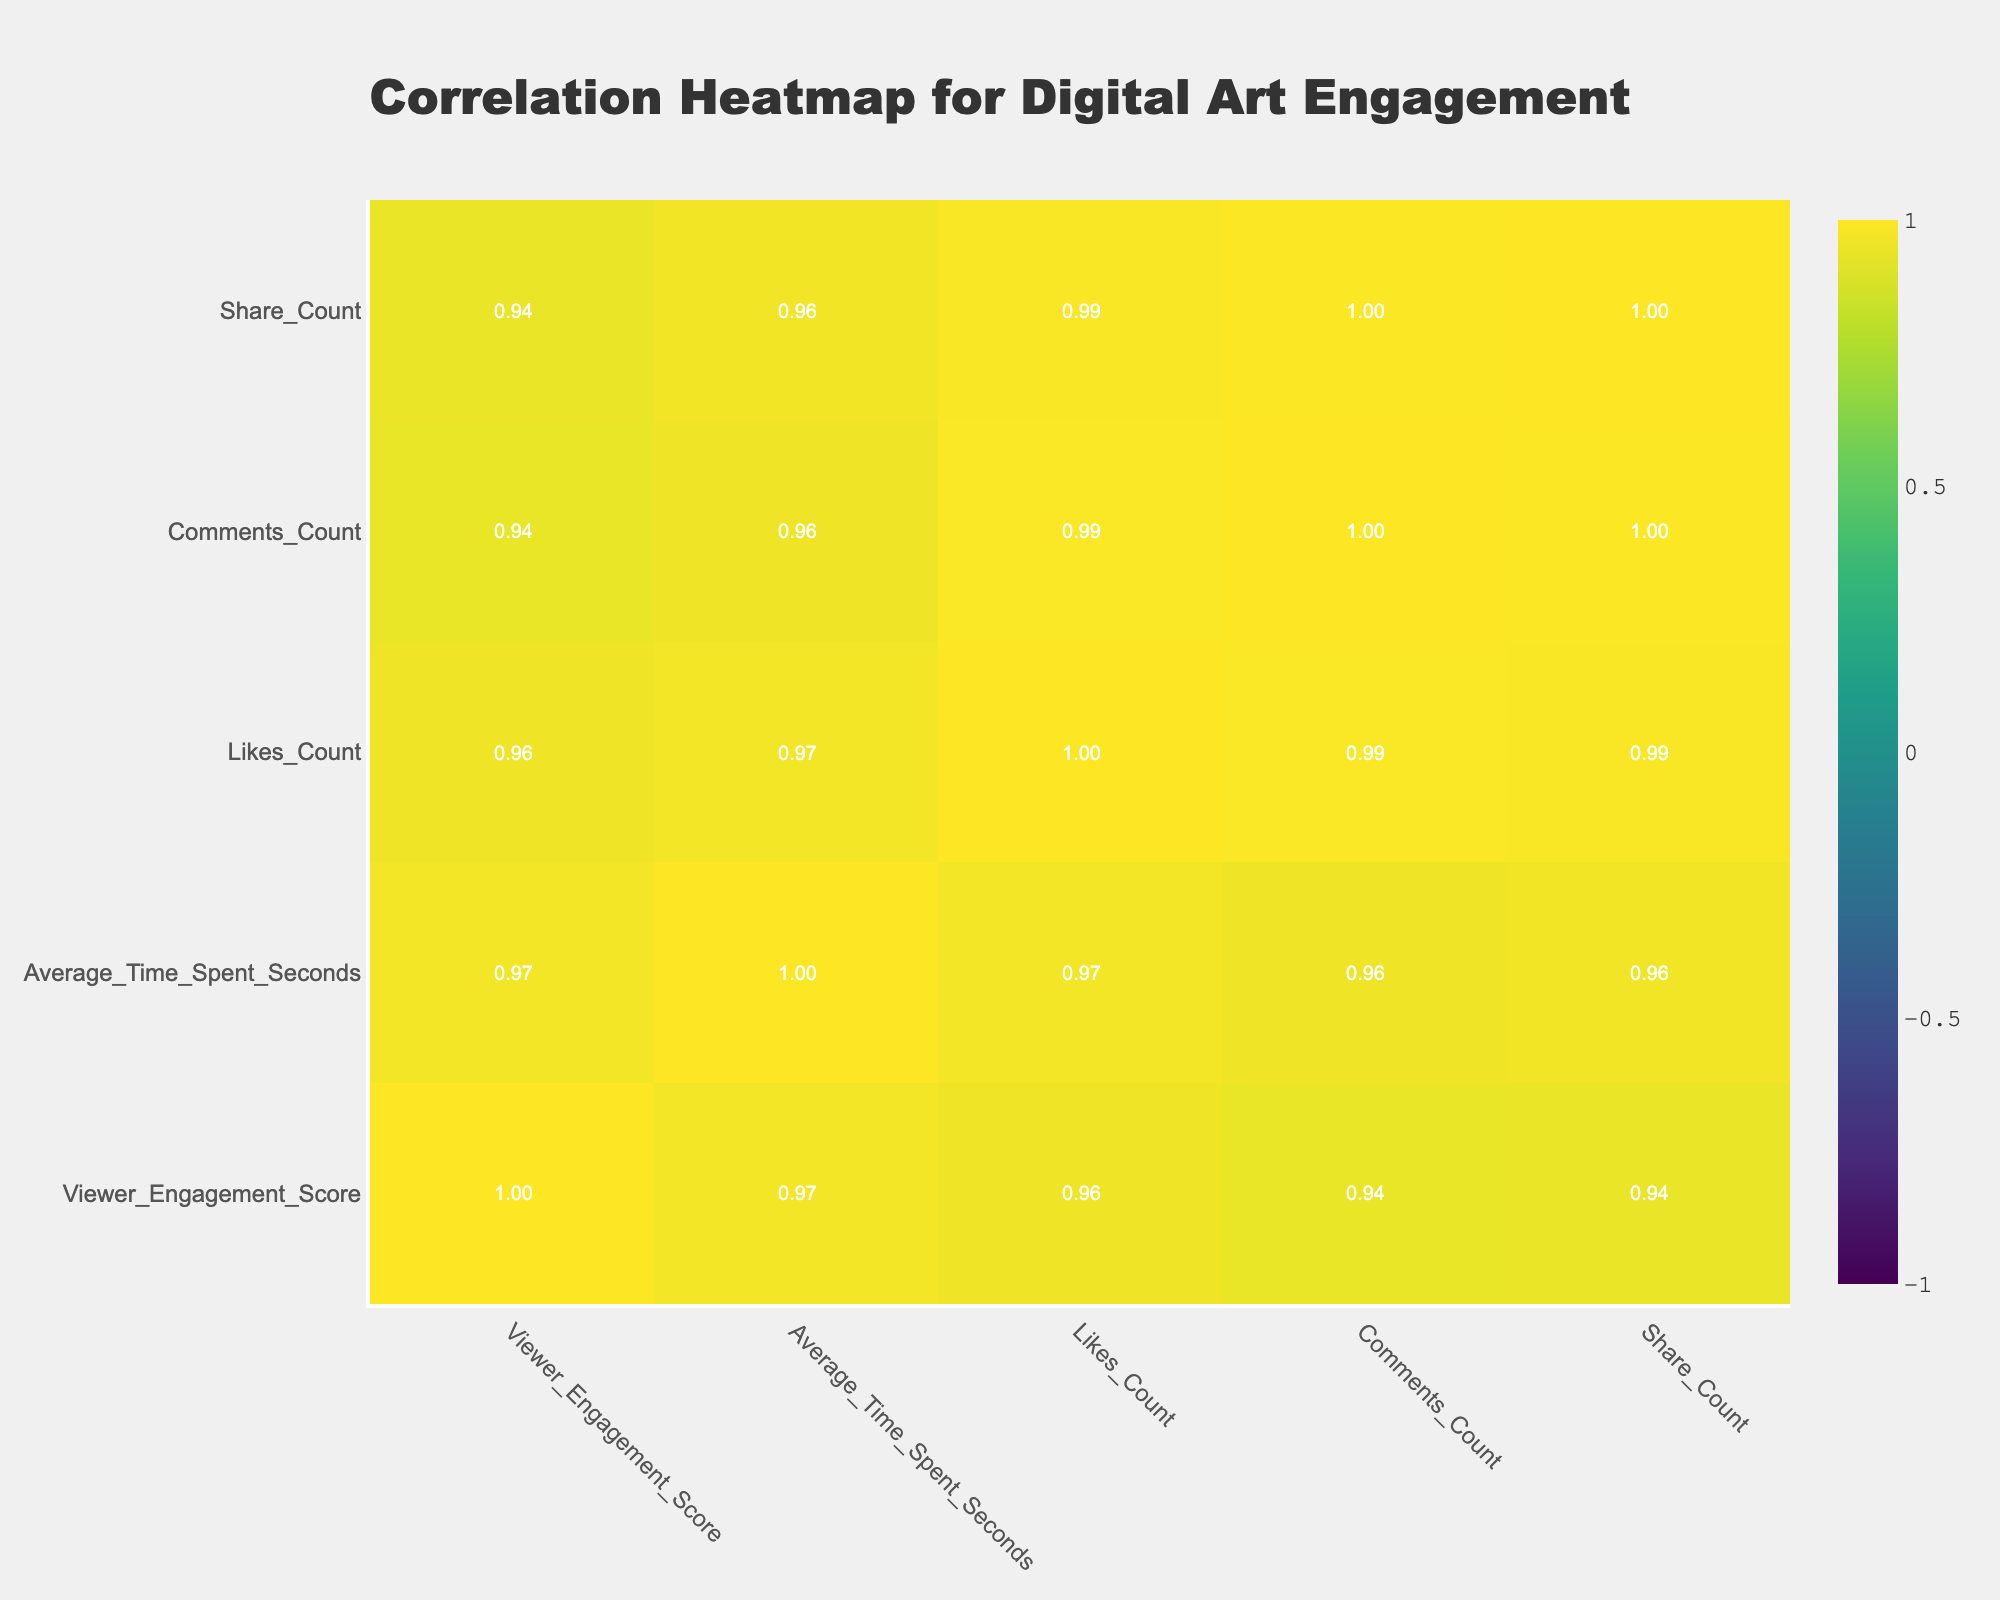What's the Viewer Engagement Score for the Neon color palette? The table shows the Neon color palette with a Viewer Engagement Score of 90.
Answer: 90 What color palette has the highest Likes Count? By checking the Likes Count column, Neon has the highest value at 250.
Answer: Neon Is the average time spent on digital art with a Muted color palette greater than 180 seconds? The average time spent for the Muted palette is 180 seconds, which is equal, not greater.
Answer: No Which color palette category has the lowest Comments Count? The table indicates that the Earthy color palette has the lowest Comments Count, standing at 3.
Answer: Earthy What is the correlation between Viewer Engagement Score and Share Count? Looking at the correlation table, the value for Viewer Engagement Score and Share Count is 0.88, indicating a strong positive correlation.
Answer: 0.88 What is the difference in Viewer Engagement Scores between the Vibrant and Monochromatic color palettes? Vibrant has a score of 76 while Monochromatic has 70. The difference is 76 - 70 = 6.
Answer: 6 Are there more color palettes with Viewer Engagement Scores above 70 than below 60? Color palettes above 70 are Vibrant, Complementary, Analogous, and Neon (4), whereas below 60 are Muted, Triadic, and Black and White (3).
Answer: Yes Which color palettes fall within the range of 60 to 70 Viewer Engagement Scores? Checking the Viewer Engagement Score column, Pastel (65), Monochromatic (70), and Triadic (60) fall within this range.
Answer: Pastel, Monochromatic, Triadic Calculate the average Likes Count for the color palettes with a Viewer Engagement Score greater than 70. The palettes with scores greater than 70 are Vibrant (150), Complementary (200), Analogous (160), and Neon (250). The sum is 150 + 200 + 160 + 250 = 760, and there are 4 palettes, so the average is 760/4 = 190.
Answer: 190 